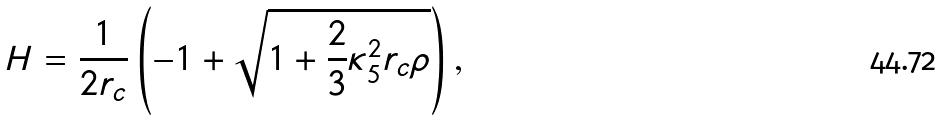Convert formula to latex. <formula><loc_0><loc_0><loc_500><loc_500>H = \frac { 1 } { 2 r _ { c } } \left ( - 1 + \sqrt { 1 + \frac { 2 } { 3 } \kappa _ { 5 } ^ { 2 } r _ { c } \rho } \right ) ,</formula> 